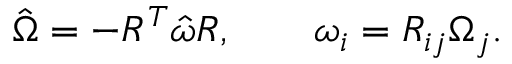Convert formula to latex. <formula><loc_0><loc_0><loc_500><loc_500>\begin{array} { r } { \hat { \Omega } = - R ^ { T } \hat { \omega } R , \quad \omega _ { i } = R _ { i j } \Omega _ { j } . } \end{array}</formula> 